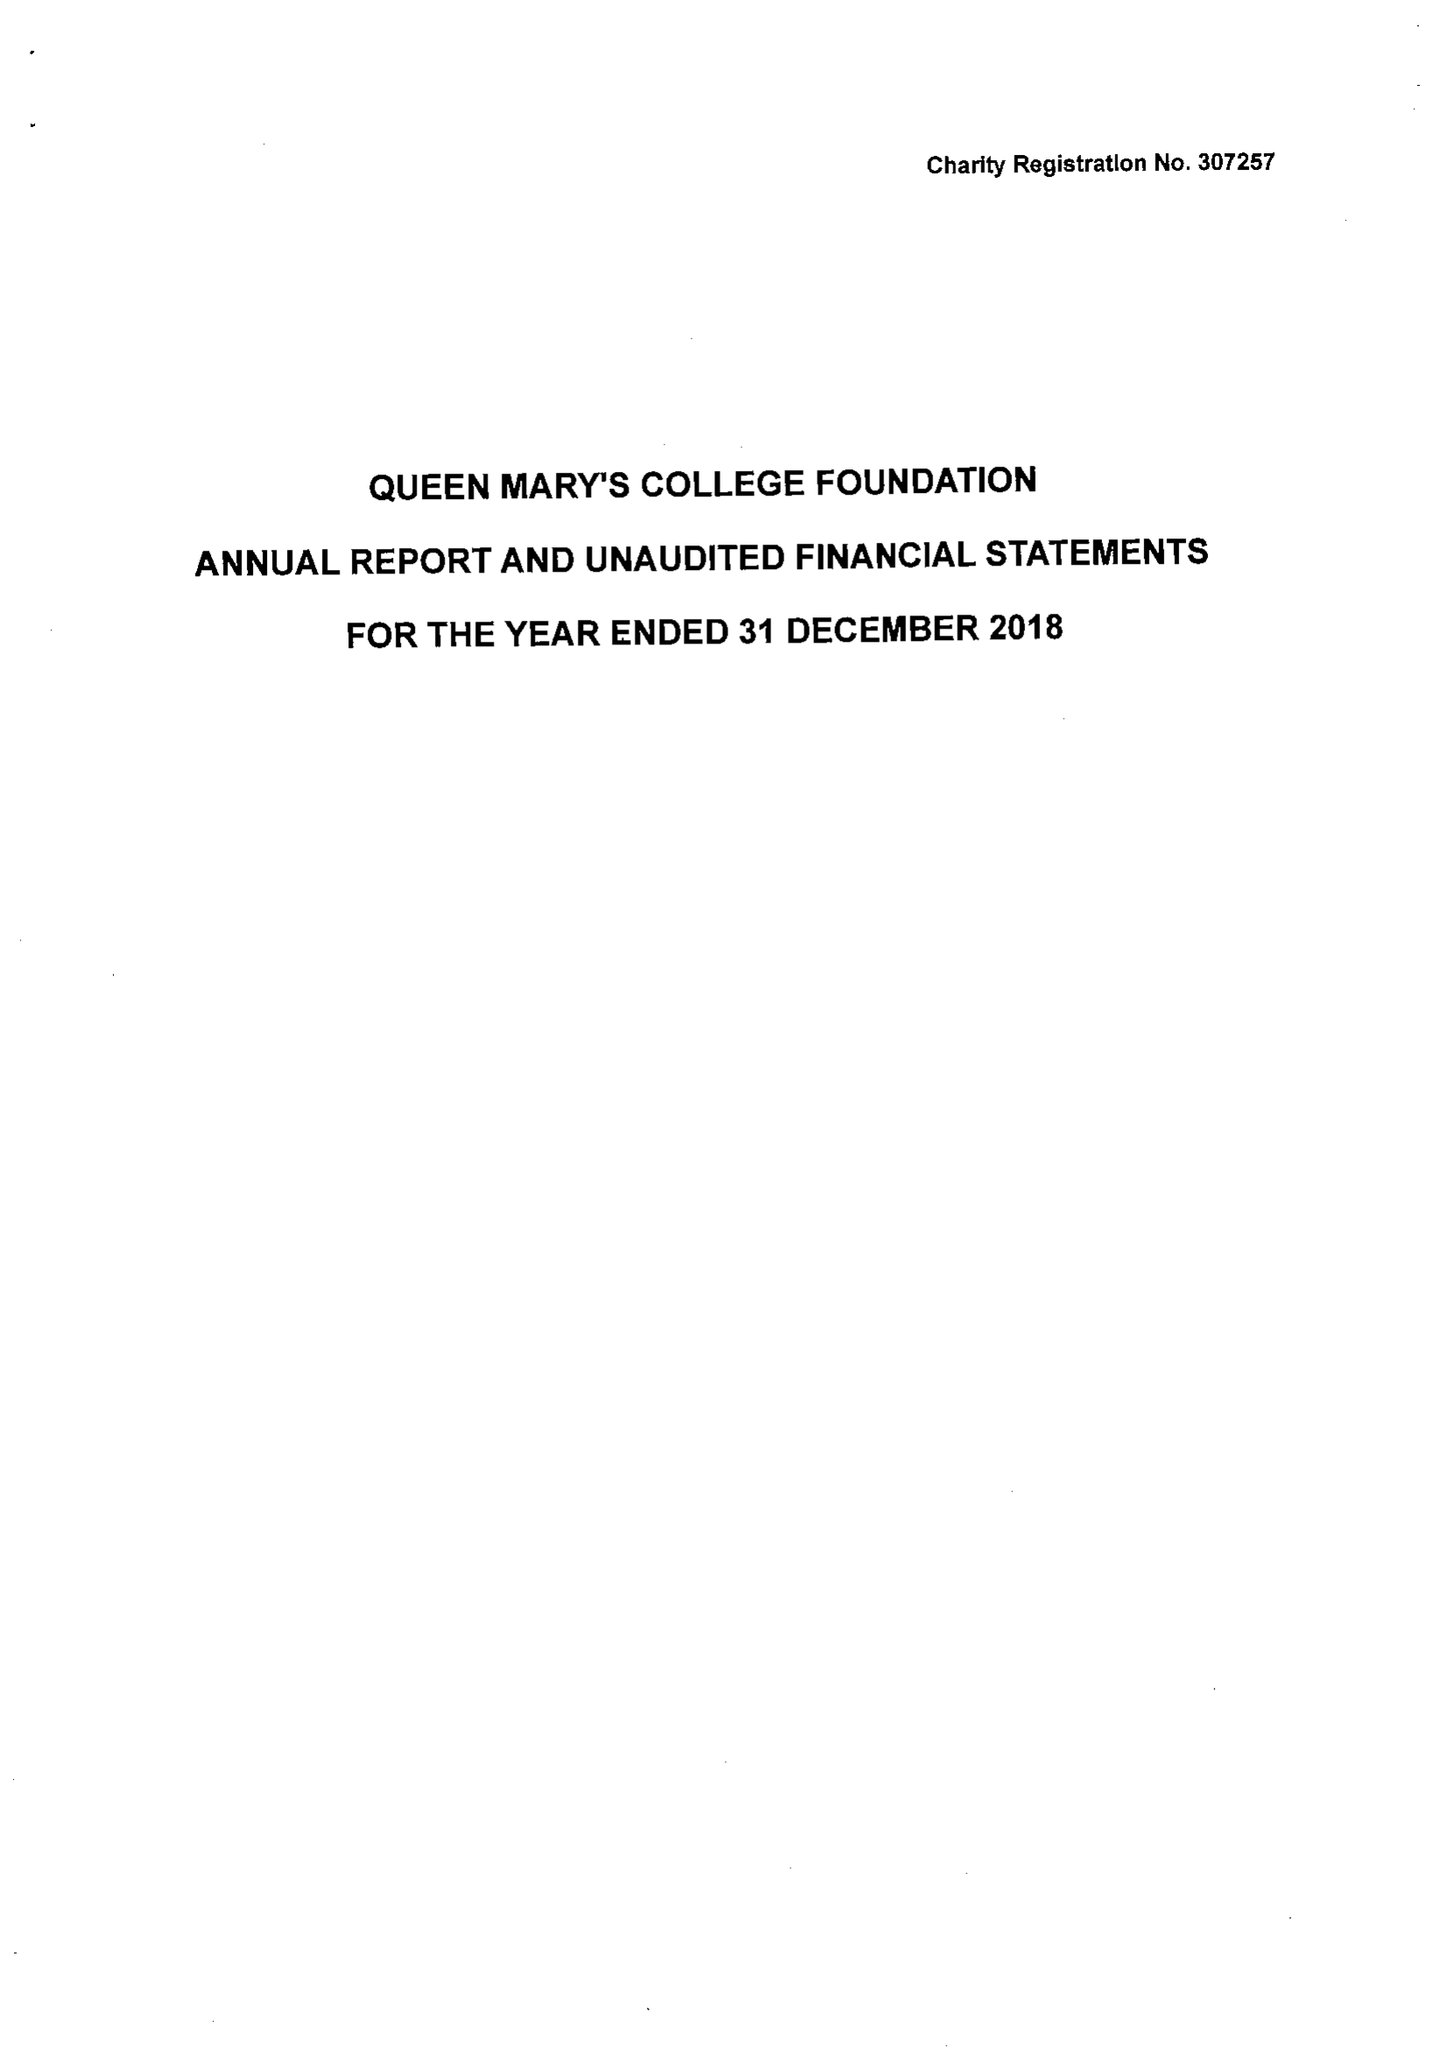What is the value for the address__post_town?
Answer the question using a single word or phrase. BASINGSTOKE 